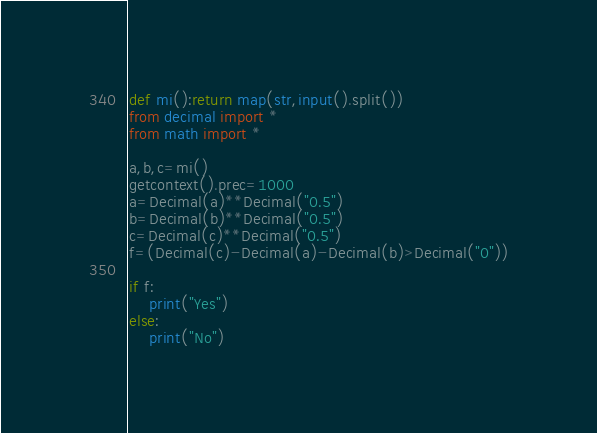Convert code to text. <code><loc_0><loc_0><loc_500><loc_500><_Python_>def mi():return map(str,input().split())
from decimal import *
from math import *

a,b,c=mi()
getcontext().prec=1000
a=Decimal(a)**Decimal("0.5")
b=Decimal(b)**Decimal("0.5")
c=Decimal(c)**Decimal("0.5")
f=(Decimal(c)-Decimal(a)-Decimal(b)>Decimal("0"))

if f:
    print("Yes")
else:
    print("No")


</code> 